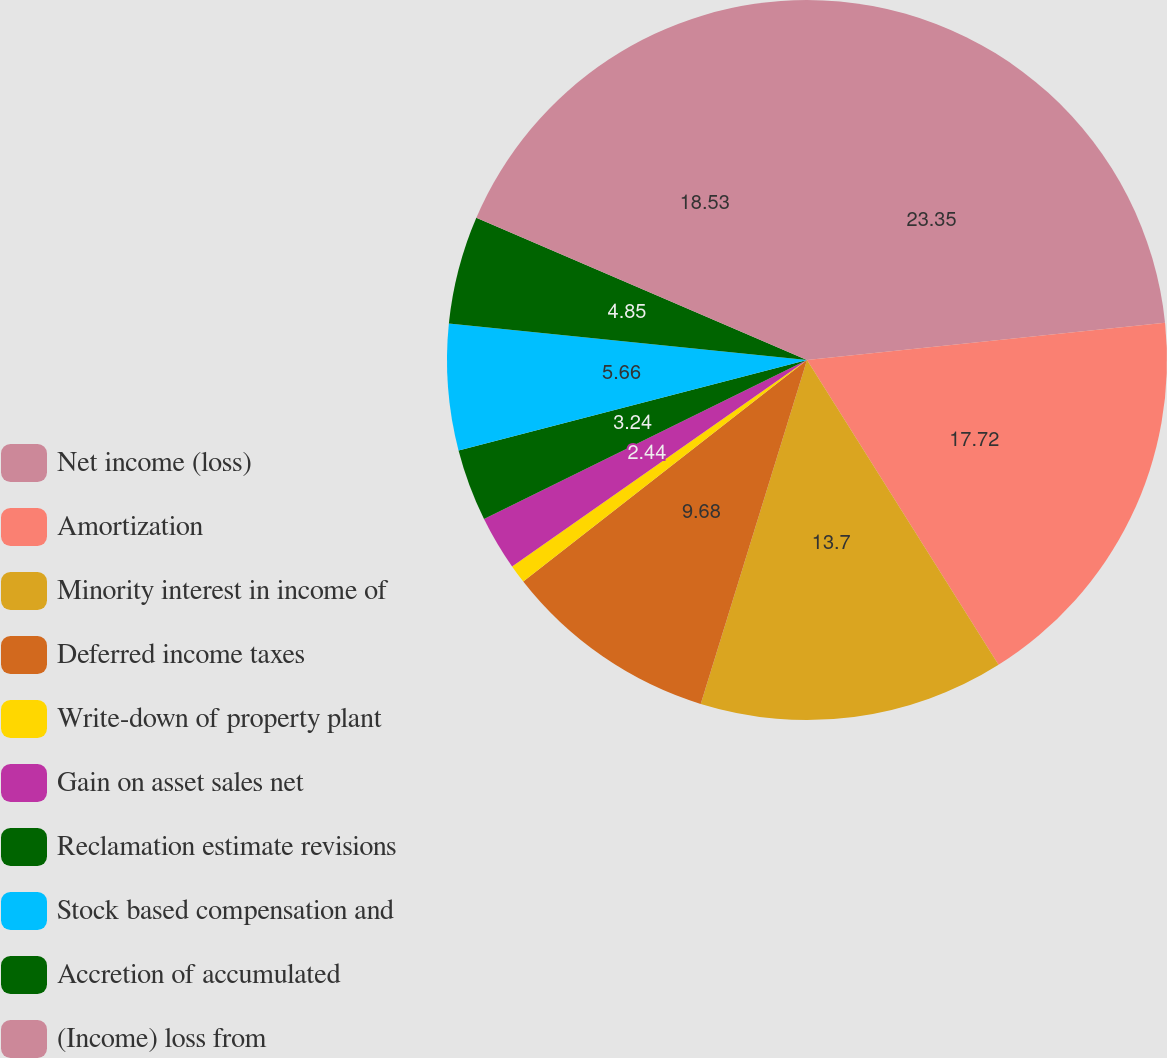<chart> <loc_0><loc_0><loc_500><loc_500><pie_chart><fcel>Net income (loss)<fcel>Amortization<fcel>Minority interest in income of<fcel>Deferred income taxes<fcel>Write-down of property plant<fcel>Gain on asset sales net<fcel>Reclamation estimate revisions<fcel>Stock based compensation and<fcel>Accretion of accumulated<fcel>(Income) loss from<nl><fcel>23.35%<fcel>17.72%<fcel>13.7%<fcel>9.68%<fcel>0.83%<fcel>2.44%<fcel>3.24%<fcel>5.66%<fcel>4.85%<fcel>18.53%<nl></chart> 